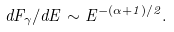<formula> <loc_0><loc_0><loc_500><loc_500>d F _ { \gamma } / d E \sim E ^ { - ( \alpha + 1 ) / 2 } .</formula> 